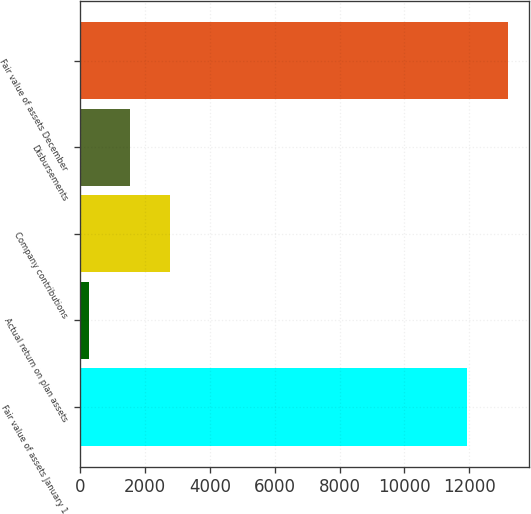Convert chart to OTSL. <chart><loc_0><loc_0><loc_500><loc_500><bar_chart><fcel>Fair value of assets January 1<fcel>Actual return on plan assets<fcel>Company contributions<fcel>Disbursements<fcel>Fair value of assets December<nl><fcel>11934<fcel>271<fcel>2776.4<fcel>1523.7<fcel>13186.7<nl></chart> 